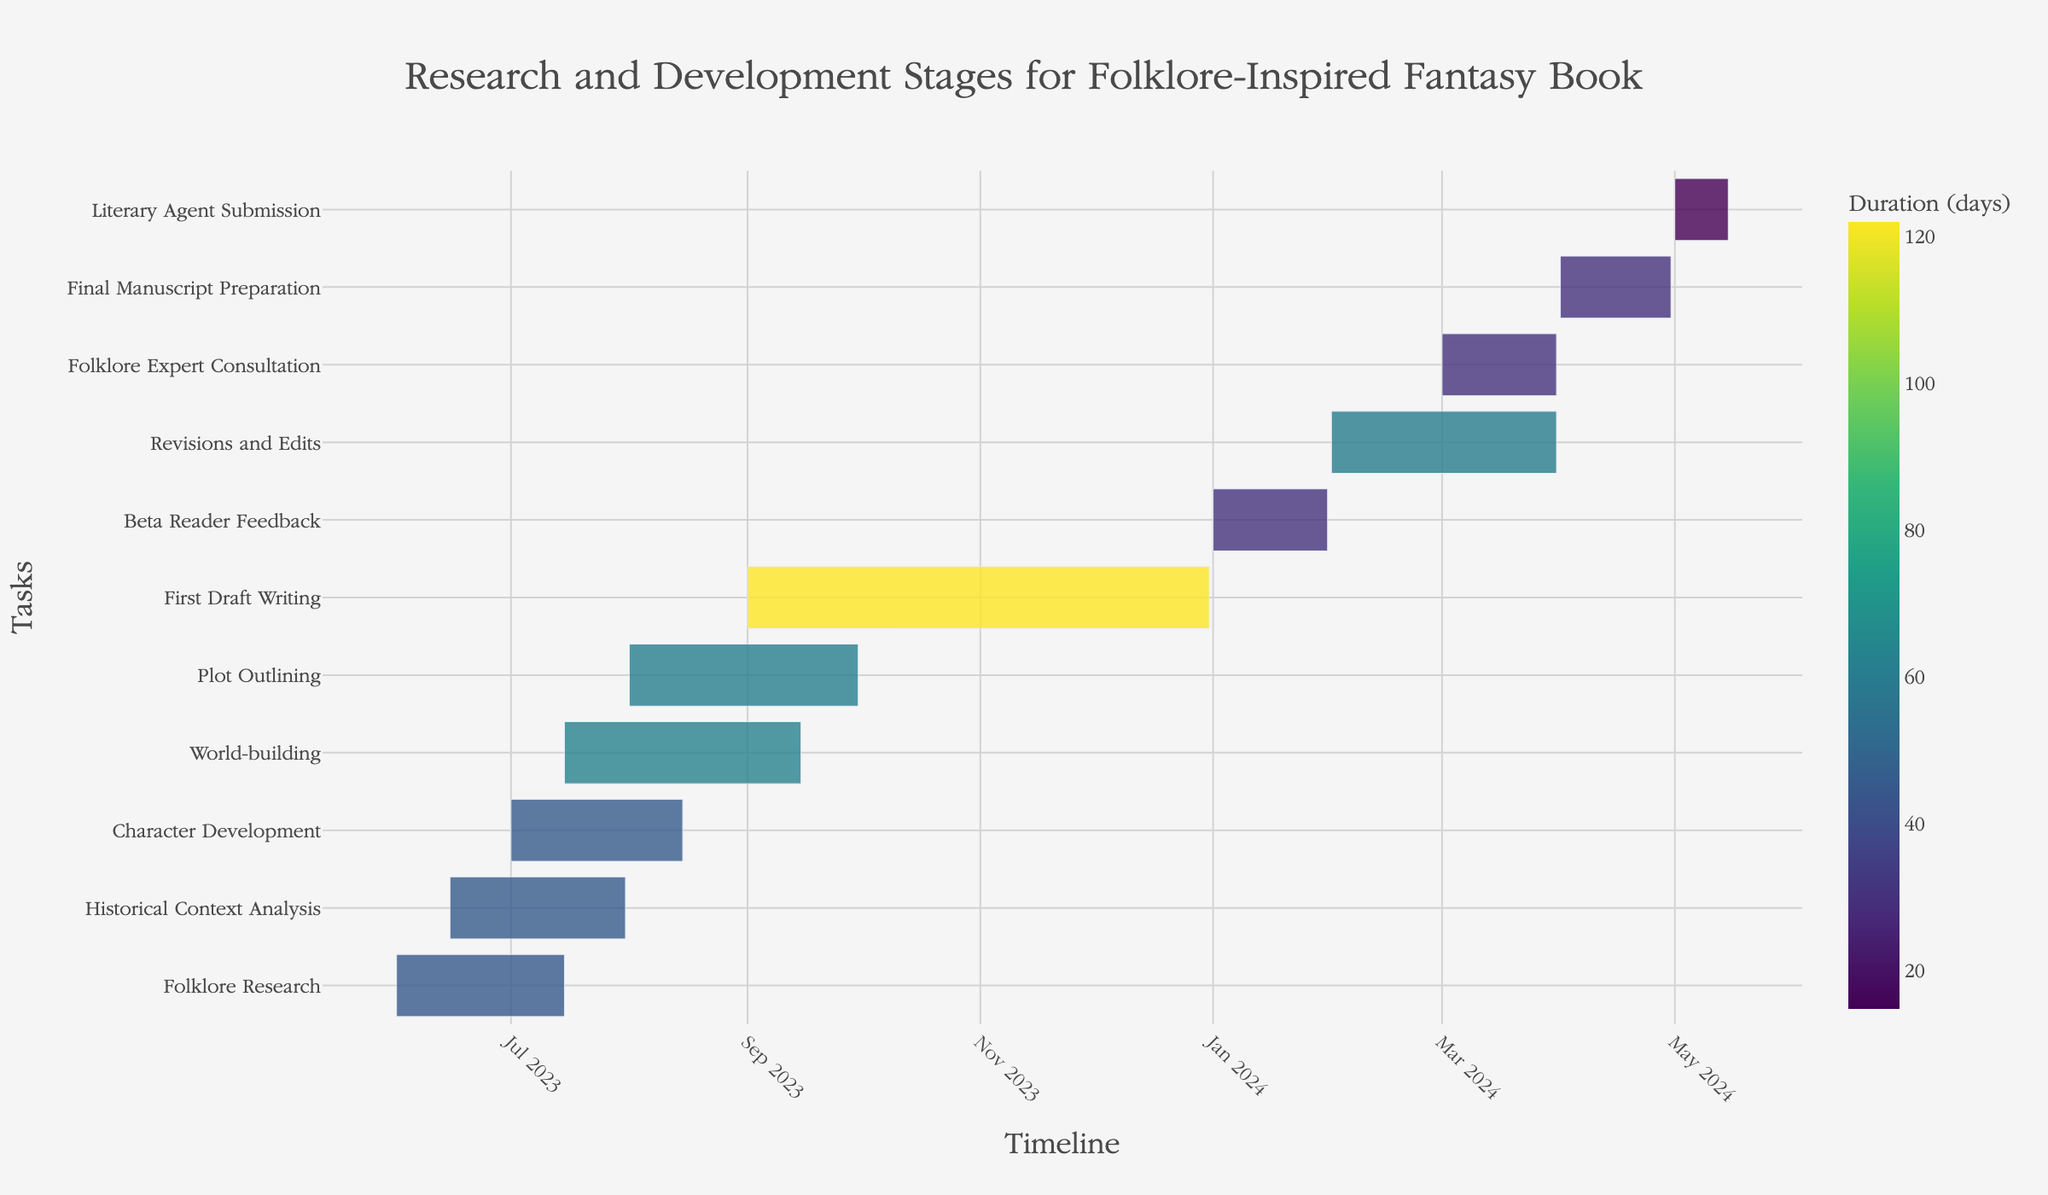What is the title of the Gantt Chart? The title is usually located at the top of the chart and is often larger and bolder than the rest of the text. Here, it reads "Research and Development Stages for Folklore-Inspired Fantasy Book."
Answer: Research and Development Stages for Folklore-Inspired Fantasy Book Which task has the shortest duration? In a Gantt Chart, the shorter durations are represented by shorter bars. Comparing all tasks, "Literary Agent Submission" is the shortest.
Answer: Literary Agent Submission How many days does the "Character Development" stage last? The duration in days can be found by checking the bar's length in the chart, or from the data directly, which shows "Character Development" lasts for 46 days.
Answer: 46 days Between which dates does "World-building" occur? The start and end dates of a task are often displayed along the bar's width. "World-building" starts on 2023-07-15 and ends on 2023-09-15.
Answer: 2023-07-15 to 2023-09-15 Which task occurs immediately after "First Draft Writing"? By looking at the timeline, "Beta Reader Feedback" starts immediately after the end of "First Draft Writing."
Answer: Beta Reader Feedback What is the total duration of "First Draft Writing" and "Beta Reader Feedback" combined? "First Draft Writing" lasts 122 days and "Beta Reader Feedback" lasts 31 days. Combined, it's 122 + 31 = 153 days.
Answer: 153 days How many tasks have a duration of more than 60 days? By examining each bar's length and color intensity related to days, tasks with more than 60 days are "World-building," "Plot Outlining," and "First Draft Writing." There are 3 tasks in total.
Answer: 3 tasks Which task spans the months of both February and March 2024? Checking the dates for each task, "Revisions and Edits" spans both February and March.
Answer: Revisions and Edits How much overlap is there between "Historical Context Analysis" and "Character Development"? "Historical Context Analysis" runs from 2023-06-15 to 2023-07-31, and "Character Development" runs from 2023-07-01 to 2023-08-15. The overlapping period is from 2023-07-01 to 2023-07-31, which is 31 days.
Answer: 31 days What task starts immediately before "Final Manuscript Preparation"? "Revisions and Edits" ends right before "Final Manuscript Preparation" starts.
Answer: Revisions and Edits 